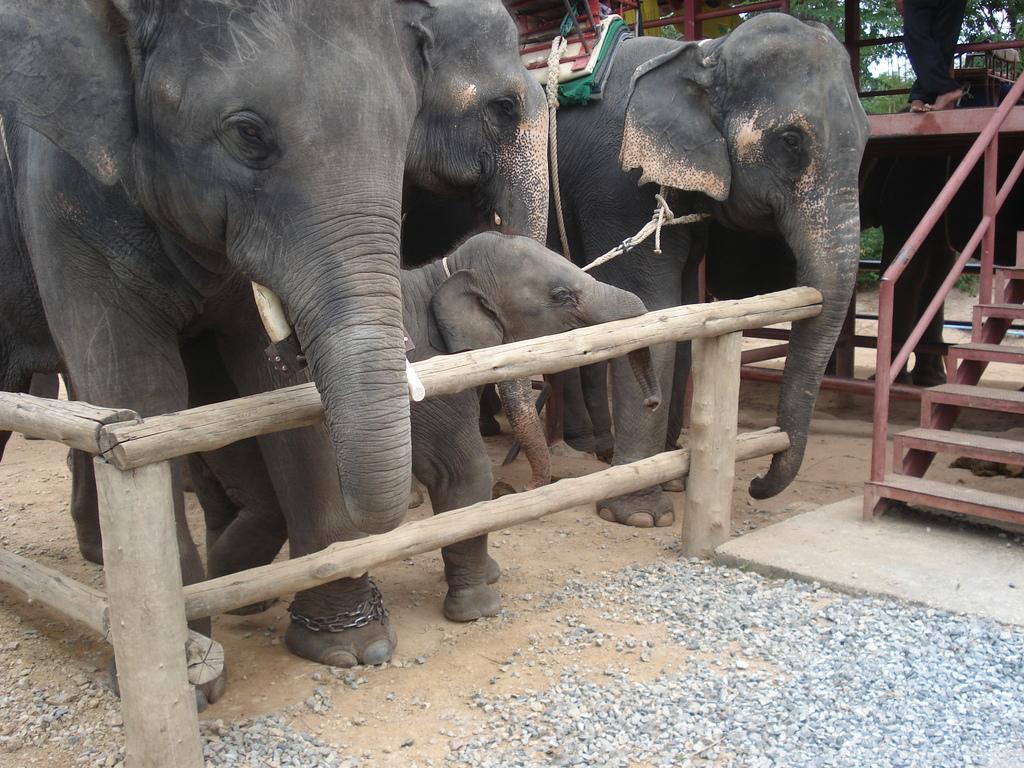Could you give a brief overview of what you see in this image? In this image we can see elephants, fence, stones, and a staircase. At the top of the image we can see legs of a person, trees, and sky. 